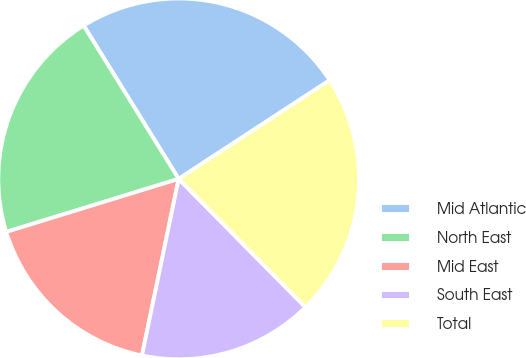Convert chart. <chart><loc_0><loc_0><loc_500><loc_500><pie_chart><fcel>Mid Atlantic<fcel>North East<fcel>Mid East<fcel>South East<fcel>Total<nl><fcel>24.62%<fcel>20.92%<fcel>16.99%<fcel>15.67%<fcel>21.81%<nl></chart> 